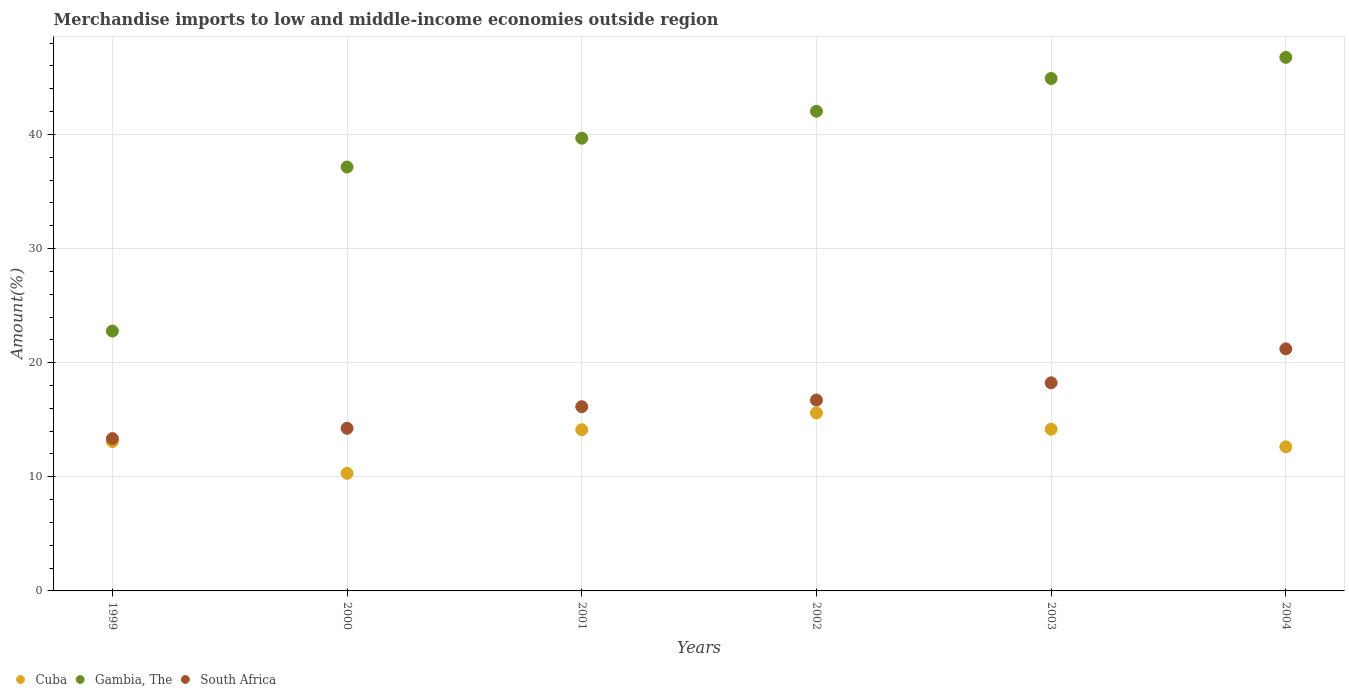What is the percentage of amount earned from merchandise imports in South Africa in 2003?
Offer a very short reply. 18.24. Across all years, what is the maximum percentage of amount earned from merchandise imports in Cuba?
Your answer should be very brief. 15.6. Across all years, what is the minimum percentage of amount earned from merchandise imports in South Africa?
Provide a succinct answer. 13.35. In which year was the percentage of amount earned from merchandise imports in South Africa maximum?
Keep it short and to the point. 2004. In which year was the percentage of amount earned from merchandise imports in South Africa minimum?
Keep it short and to the point. 1999. What is the total percentage of amount earned from merchandise imports in Gambia, The in the graph?
Provide a short and direct response. 233.27. What is the difference between the percentage of amount earned from merchandise imports in South Africa in 2000 and that in 2002?
Make the answer very short. -2.48. What is the difference between the percentage of amount earned from merchandise imports in Gambia, The in 2004 and the percentage of amount earned from merchandise imports in South Africa in 2000?
Make the answer very short. 32.5. What is the average percentage of amount earned from merchandise imports in Gambia, The per year?
Offer a terse response. 38.88. In the year 2001, what is the difference between the percentage of amount earned from merchandise imports in Gambia, The and percentage of amount earned from merchandise imports in South Africa?
Ensure brevity in your answer.  23.53. In how many years, is the percentage of amount earned from merchandise imports in South Africa greater than 4 %?
Provide a succinct answer. 6. What is the ratio of the percentage of amount earned from merchandise imports in South Africa in 2000 to that in 2002?
Ensure brevity in your answer.  0.85. Is the difference between the percentage of amount earned from merchandise imports in Gambia, The in 1999 and 2004 greater than the difference between the percentage of amount earned from merchandise imports in South Africa in 1999 and 2004?
Provide a short and direct response. No. What is the difference between the highest and the second highest percentage of amount earned from merchandise imports in Cuba?
Offer a terse response. 1.43. What is the difference between the highest and the lowest percentage of amount earned from merchandise imports in South Africa?
Offer a very short reply. 7.86. In how many years, is the percentage of amount earned from merchandise imports in Cuba greater than the average percentage of amount earned from merchandise imports in Cuba taken over all years?
Make the answer very short. 3. Is the sum of the percentage of amount earned from merchandise imports in Cuba in 1999 and 2000 greater than the maximum percentage of amount earned from merchandise imports in Gambia, The across all years?
Your answer should be compact. No. Is the percentage of amount earned from merchandise imports in South Africa strictly less than the percentage of amount earned from merchandise imports in Gambia, The over the years?
Your response must be concise. Yes. How many dotlines are there?
Your response must be concise. 3. What is the difference between two consecutive major ticks on the Y-axis?
Make the answer very short. 10. Are the values on the major ticks of Y-axis written in scientific E-notation?
Give a very brief answer. No. Does the graph contain any zero values?
Keep it short and to the point. No. Does the graph contain grids?
Your answer should be compact. Yes. Where does the legend appear in the graph?
Your response must be concise. Bottom left. How are the legend labels stacked?
Give a very brief answer. Horizontal. What is the title of the graph?
Offer a terse response. Merchandise imports to low and middle-income economies outside region. Does "Cameroon" appear as one of the legend labels in the graph?
Provide a succinct answer. No. What is the label or title of the X-axis?
Provide a short and direct response. Years. What is the label or title of the Y-axis?
Ensure brevity in your answer.  Amount(%). What is the Amount(%) of Cuba in 1999?
Give a very brief answer. 13.09. What is the Amount(%) in Gambia, The in 1999?
Provide a short and direct response. 22.77. What is the Amount(%) in South Africa in 1999?
Your answer should be very brief. 13.35. What is the Amount(%) of Cuba in 2000?
Offer a very short reply. 10.3. What is the Amount(%) in Gambia, The in 2000?
Provide a short and direct response. 37.14. What is the Amount(%) of South Africa in 2000?
Keep it short and to the point. 14.25. What is the Amount(%) in Cuba in 2001?
Offer a very short reply. 14.12. What is the Amount(%) in Gambia, The in 2001?
Make the answer very short. 39.67. What is the Amount(%) in South Africa in 2001?
Your answer should be compact. 16.14. What is the Amount(%) in Cuba in 2002?
Give a very brief answer. 15.6. What is the Amount(%) of Gambia, The in 2002?
Offer a very short reply. 42.03. What is the Amount(%) of South Africa in 2002?
Make the answer very short. 16.73. What is the Amount(%) in Cuba in 2003?
Provide a succinct answer. 14.17. What is the Amount(%) in Gambia, The in 2003?
Keep it short and to the point. 44.9. What is the Amount(%) of South Africa in 2003?
Offer a very short reply. 18.24. What is the Amount(%) in Cuba in 2004?
Your answer should be compact. 12.63. What is the Amount(%) in Gambia, The in 2004?
Your response must be concise. 46.75. What is the Amount(%) of South Africa in 2004?
Your answer should be very brief. 21.21. Across all years, what is the maximum Amount(%) of Cuba?
Your answer should be compact. 15.6. Across all years, what is the maximum Amount(%) in Gambia, The?
Provide a succinct answer. 46.75. Across all years, what is the maximum Amount(%) of South Africa?
Offer a terse response. 21.21. Across all years, what is the minimum Amount(%) in Cuba?
Offer a very short reply. 10.3. Across all years, what is the minimum Amount(%) of Gambia, The?
Offer a very short reply. 22.77. Across all years, what is the minimum Amount(%) of South Africa?
Offer a terse response. 13.35. What is the total Amount(%) in Cuba in the graph?
Ensure brevity in your answer.  79.91. What is the total Amount(%) in Gambia, The in the graph?
Keep it short and to the point. 233.27. What is the total Amount(%) of South Africa in the graph?
Keep it short and to the point. 99.91. What is the difference between the Amount(%) of Cuba in 1999 and that in 2000?
Keep it short and to the point. 2.79. What is the difference between the Amount(%) in Gambia, The in 1999 and that in 2000?
Your answer should be compact. -14.37. What is the difference between the Amount(%) in South Africa in 1999 and that in 2000?
Your answer should be very brief. -0.9. What is the difference between the Amount(%) in Cuba in 1999 and that in 2001?
Make the answer very short. -1.04. What is the difference between the Amount(%) of Gambia, The in 1999 and that in 2001?
Offer a very short reply. -16.9. What is the difference between the Amount(%) in South Africa in 1999 and that in 2001?
Keep it short and to the point. -2.79. What is the difference between the Amount(%) in Cuba in 1999 and that in 2002?
Provide a short and direct response. -2.51. What is the difference between the Amount(%) of Gambia, The in 1999 and that in 2002?
Your answer should be compact. -19.26. What is the difference between the Amount(%) in South Africa in 1999 and that in 2002?
Give a very brief answer. -3.38. What is the difference between the Amount(%) in Cuba in 1999 and that in 2003?
Your answer should be compact. -1.08. What is the difference between the Amount(%) in Gambia, The in 1999 and that in 2003?
Offer a very short reply. -22.13. What is the difference between the Amount(%) of South Africa in 1999 and that in 2003?
Ensure brevity in your answer.  -4.89. What is the difference between the Amount(%) of Cuba in 1999 and that in 2004?
Your answer should be very brief. 0.46. What is the difference between the Amount(%) of Gambia, The in 1999 and that in 2004?
Offer a terse response. -23.98. What is the difference between the Amount(%) of South Africa in 1999 and that in 2004?
Your response must be concise. -7.86. What is the difference between the Amount(%) in Cuba in 2000 and that in 2001?
Your answer should be compact. -3.82. What is the difference between the Amount(%) in Gambia, The in 2000 and that in 2001?
Keep it short and to the point. -2.52. What is the difference between the Amount(%) of South Africa in 2000 and that in 2001?
Offer a very short reply. -1.89. What is the difference between the Amount(%) of Cuba in 2000 and that in 2002?
Your answer should be compact. -5.29. What is the difference between the Amount(%) in Gambia, The in 2000 and that in 2002?
Offer a very short reply. -4.89. What is the difference between the Amount(%) in South Africa in 2000 and that in 2002?
Your answer should be very brief. -2.48. What is the difference between the Amount(%) in Cuba in 2000 and that in 2003?
Offer a terse response. -3.86. What is the difference between the Amount(%) of Gambia, The in 2000 and that in 2003?
Make the answer very short. -7.76. What is the difference between the Amount(%) of South Africa in 2000 and that in 2003?
Offer a very short reply. -3.99. What is the difference between the Amount(%) of Cuba in 2000 and that in 2004?
Provide a succinct answer. -2.32. What is the difference between the Amount(%) of Gambia, The in 2000 and that in 2004?
Keep it short and to the point. -9.61. What is the difference between the Amount(%) of South Africa in 2000 and that in 2004?
Your answer should be very brief. -6.96. What is the difference between the Amount(%) of Cuba in 2001 and that in 2002?
Provide a short and direct response. -1.47. What is the difference between the Amount(%) of Gambia, The in 2001 and that in 2002?
Make the answer very short. -2.36. What is the difference between the Amount(%) in South Africa in 2001 and that in 2002?
Provide a succinct answer. -0.59. What is the difference between the Amount(%) in Cuba in 2001 and that in 2003?
Give a very brief answer. -0.04. What is the difference between the Amount(%) in Gambia, The in 2001 and that in 2003?
Make the answer very short. -5.23. What is the difference between the Amount(%) in South Africa in 2001 and that in 2003?
Provide a succinct answer. -2.1. What is the difference between the Amount(%) in Cuba in 2001 and that in 2004?
Your response must be concise. 1.5. What is the difference between the Amount(%) of Gambia, The in 2001 and that in 2004?
Keep it short and to the point. -7.08. What is the difference between the Amount(%) in South Africa in 2001 and that in 2004?
Keep it short and to the point. -5.07. What is the difference between the Amount(%) of Cuba in 2002 and that in 2003?
Keep it short and to the point. 1.43. What is the difference between the Amount(%) in Gambia, The in 2002 and that in 2003?
Provide a succinct answer. -2.87. What is the difference between the Amount(%) in South Africa in 2002 and that in 2003?
Make the answer very short. -1.51. What is the difference between the Amount(%) in Cuba in 2002 and that in 2004?
Keep it short and to the point. 2.97. What is the difference between the Amount(%) in Gambia, The in 2002 and that in 2004?
Keep it short and to the point. -4.72. What is the difference between the Amount(%) of South Africa in 2002 and that in 2004?
Your answer should be compact. -4.48. What is the difference between the Amount(%) of Cuba in 2003 and that in 2004?
Give a very brief answer. 1.54. What is the difference between the Amount(%) in Gambia, The in 2003 and that in 2004?
Offer a terse response. -1.85. What is the difference between the Amount(%) in South Africa in 2003 and that in 2004?
Ensure brevity in your answer.  -2.97. What is the difference between the Amount(%) in Cuba in 1999 and the Amount(%) in Gambia, The in 2000?
Your answer should be very brief. -24.05. What is the difference between the Amount(%) of Cuba in 1999 and the Amount(%) of South Africa in 2000?
Offer a terse response. -1.16. What is the difference between the Amount(%) of Gambia, The in 1999 and the Amount(%) of South Africa in 2000?
Your answer should be compact. 8.52. What is the difference between the Amount(%) in Cuba in 1999 and the Amount(%) in Gambia, The in 2001?
Offer a terse response. -26.58. What is the difference between the Amount(%) in Cuba in 1999 and the Amount(%) in South Africa in 2001?
Ensure brevity in your answer.  -3.05. What is the difference between the Amount(%) in Gambia, The in 1999 and the Amount(%) in South Africa in 2001?
Offer a terse response. 6.63. What is the difference between the Amount(%) in Cuba in 1999 and the Amount(%) in Gambia, The in 2002?
Keep it short and to the point. -28.94. What is the difference between the Amount(%) in Cuba in 1999 and the Amount(%) in South Africa in 2002?
Ensure brevity in your answer.  -3.64. What is the difference between the Amount(%) of Gambia, The in 1999 and the Amount(%) of South Africa in 2002?
Offer a terse response. 6.04. What is the difference between the Amount(%) of Cuba in 1999 and the Amount(%) of Gambia, The in 2003?
Your answer should be very brief. -31.81. What is the difference between the Amount(%) of Cuba in 1999 and the Amount(%) of South Africa in 2003?
Keep it short and to the point. -5.15. What is the difference between the Amount(%) in Gambia, The in 1999 and the Amount(%) in South Africa in 2003?
Provide a short and direct response. 4.53. What is the difference between the Amount(%) in Cuba in 1999 and the Amount(%) in Gambia, The in 2004?
Give a very brief answer. -33.66. What is the difference between the Amount(%) of Cuba in 1999 and the Amount(%) of South Africa in 2004?
Your response must be concise. -8.12. What is the difference between the Amount(%) in Gambia, The in 1999 and the Amount(%) in South Africa in 2004?
Provide a short and direct response. 1.56. What is the difference between the Amount(%) in Cuba in 2000 and the Amount(%) in Gambia, The in 2001?
Your response must be concise. -29.36. What is the difference between the Amount(%) in Cuba in 2000 and the Amount(%) in South Africa in 2001?
Your answer should be very brief. -5.84. What is the difference between the Amount(%) of Gambia, The in 2000 and the Amount(%) of South Africa in 2001?
Your answer should be compact. 21. What is the difference between the Amount(%) in Cuba in 2000 and the Amount(%) in Gambia, The in 2002?
Your answer should be very brief. -31.73. What is the difference between the Amount(%) of Cuba in 2000 and the Amount(%) of South Africa in 2002?
Your response must be concise. -6.42. What is the difference between the Amount(%) of Gambia, The in 2000 and the Amount(%) of South Africa in 2002?
Make the answer very short. 20.42. What is the difference between the Amount(%) in Cuba in 2000 and the Amount(%) in Gambia, The in 2003?
Give a very brief answer. -34.6. What is the difference between the Amount(%) in Cuba in 2000 and the Amount(%) in South Africa in 2003?
Your answer should be compact. -7.93. What is the difference between the Amount(%) of Gambia, The in 2000 and the Amount(%) of South Africa in 2003?
Provide a succinct answer. 18.91. What is the difference between the Amount(%) of Cuba in 2000 and the Amount(%) of Gambia, The in 2004?
Provide a short and direct response. -36.45. What is the difference between the Amount(%) in Cuba in 2000 and the Amount(%) in South Africa in 2004?
Your answer should be compact. -10.91. What is the difference between the Amount(%) in Gambia, The in 2000 and the Amount(%) in South Africa in 2004?
Make the answer very short. 15.93. What is the difference between the Amount(%) of Cuba in 2001 and the Amount(%) of Gambia, The in 2002?
Offer a very short reply. -27.91. What is the difference between the Amount(%) of Cuba in 2001 and the Amount(%) of South Africa in 2002?
Your answer should be compact. -2.6. What is the difference between the Amount(%) of Gambia, The in 2001 and the Amount(%) of South Africa in 2002?
Your response must be concise. 22.94. What is the difference between the Amount(%) in Cuba in 2001 and the Amount(%) in Gambia, The in 2003?
Make the answer very short. -30.78. What is the difference between the Amount(%) in Cuba in 2001 and the Amount(%) in South Africa in 2003?
Offer a very short reply. -4.11. What is the difference between the Amount(%) in Gambia, The in 2001 and the Amount(%) in South Africa in 2003?
Your answer should be compact. 21.43. What is the difference between the Amount(%) of Cuba in 2001 and the Amount(%) of Gambia, The in 2004?
Provide a short and direct response. -32.63. What is the difference between the Amount(%) in Cuba in 2001 and the Amount(%) in South Africa in 2004?
Your answer should be very brief. -7.09. What is the difference between the Amount(%) in Gambia, The in 2001 and the Amount(%) in South Africa in 2004?
Keep it short and to the point. 18.46. What is the difference between the Amount(%) in Cuba in 2002 and the Amount(%) in Gambia, The in 2003?
Your answer should be very brief. -29.3. What is the difference between the Amount(%) in Cuba in 2002 and the Amount(%) in South Africa in 2003?
Ensure brevity in your answer.  -2.64. What is the difference between the Amount(%) of Gambia, The in 2002 and the Amount(%) of South Africa in 2003?
Offer a terse response. 23.79. What is the difference between the Amount(%) of Cuba in 2002 and the Amount(%) of Gambia, The in 2004?
Provide a short and direct response. -31.15. What is the difference between the Amount(%) of Cuba in 2002 and the Amount(%) of South Africa in 2004?
Provide a short and direct response. -5.61. What is the difference between the Amount(%) in Gambia, The in 2002 and the Amount(%) in South Africa in 2004?
Your answer should be very brief. 20.82. What is the difference between the Amount(%) of Cuba in 2003 and the Amount(%) of Gambia, The in 2004?
Offer a terse response. -32.58. What is the difference between the Amount(%) in Cuba in 2003 and the Amount(%) in South Africa in 2004?
Offer a terse response. -7.04. What is the difference between the Amount(%) of Gambia, The in 2003 and the Amount(%) of South Africa in 2004?
Your answer should be very brief. 23.69. What is the average Amount(%) in Cuba per year?
Ensure brevity in your answer.  13.32. What is the average Amount(%) in Gambia, The per year?
Keep it short and to the point. 38.88. What is the average Amount(%) of South Africa per year?
Keep it short and to the point. 16.65. In the year 1999, what is the difference between the Amount(%) of Cuba and Amount(%) of Gambia, The?
Keep it short and to the point. -9.68. In the year 1999, what is the difference between the Amount(%) of Cuba and Amount(%) of South Africa?
Provide a succinct answer. -0.26. In the year 1999, what is the difference between the Amount(%) in Gambia, The and Amount(%) in South Africa?
Give a very brief answer. 9.42. In the year 2000, what is the difference between the Amount(%) in Cuba and Amount(%) in Gambia, The?
Your answer should be compact. -26.84. In the year 2000, what is the difference between the Amount(%) in Cuba and Amount(%) in South Africa?
Give a very brief answer. -3.95. In the year 2000, what is the difference between the Amount(%) of Gambia, The and Amount(%) of South Africa?
Make the answer very short. 22.89. In the year 2001, what is the difference between the Amount(%) of Cuba and Amount(%) of Gambia, The?
Your response must be concise. -25.54. In the year 2001, what is the difference between the Amount(%) of Cuba and Amount(%) of South Africa?
Provide a short and direct response. -2.02. In the year 2001, what is the difference between the Amount(%) in Gambia, The and Amount(%) in South Africa?
Keep it short and to the point. 23.53. In the year 2002, what is the difference between the Amount(%) of Cuba and Amount(%) of Gambia, The?
Provide a short and direct response. -26.43. In the year 2002, what is the difference between the Amount(%) in Cuba and Amount(%) in South Africa?
Offer a terse response. -1.13. In the year 2002, what is the difference between the Amount(%) of Gambia, The and Amount(%) of South Africa?
Provide a succinct answer. 25.3. In the year 2003, what is the difference between the Amount(%) of Cuba and Amount(%) of Gambia, The?
Your answer should be very brief. -30.73. In the year 2003, what is the difference between the Amount(%) in Cuba and Amount(%) in South Africa?
Make the answer very short. -4.07. In the year 2003, what is the difference between the Amount(%) in Gambia, The and Amount(%) in South Africa?
Your answer should be very brief. 26.66. In the year 2004, what is the difference between the Amount(%) of Cuba and Amount(%) of Gambia, The?
Provide a succinct answer. -34.12. In the year 2004, what is the difference between the Amount(%) of Cuba and Amount(%) of South Africa?
Make the answer very short. -8.58. In the year 2004, what is the difference between the Amount(%) of Gambia, The and Amount(%) of South Africa?
Provide a short and direct response. 25.54. What is the ratio of the Amount(%) in Cuba in 1999 to that in 2000?
Make the answer very short. 1.27. What is the ratio of the Amount(%) of Gambia, The in 1999 to that in 2000?
Provide a succinct answer. 0.61. What is the ratio of the Amount(%) in South Africa in 1999 to that in 2000?
Provide a short and direct response. 0.94. What is the ratio of the Amount(%) in Cuba in 1999 to that in 2001?
Provide a short and direct response. 0.93. What is the ratio of the Amount(%) in Gambia, The in 1999 to that in 2001?
Offer a terse response. 0.57. What is the ratio of the Amount(%) in South Africa in 1999 to that in 2001?
Offer a very short reply. 0.83. What is the ratio of the Amount(%) in Cuba in 1999 to that in 2002?
Offer a very short reply. 0.84. What is the ratio of the Amount(%) in Gambia, The in 1999 to that in 2002?
Your response must be concise. 0.54. What is the ratio of the Amount(%) of South Africa in 1999 to that in 2002?
Ensure brevity in your answer.  0.8. What is the ratio of the Amount(%) in Cuba in 1999 to that in 2003?
Your answer should be very brief. 0.92. What is the ratio of the Amount(%) of Gambia, The in 1999 to that in 2003?
Ensure brevity in your answer.  0.51. What is the ratio of the Amount(%) in South Africa in 1999 to that in 2003?
Give a very brief answer. 0.73. What is the ratio of the Amount(%) in Cuba in 1999 to that in 2004?
Offer a very short reply. 1.04. What is the ratio of the Amount(%) of Gambia, The in 1999 to that in 2004?
Offer a very short reply. 0.49. What is the ratio of the Amount(%) in South Africa in 1999 to that in 2004?
Your answer should be compact. 0.63. What is the ratio of the Amount(%) in Cuba in 2000 to that in 2001?
Make the answer very short. 0.73. What is the ratio of the Amount(%) in Gambia, The in 2000 to that in 2001?
Make the answer very short. 0.94. What is the ratio of the Amount(%) of South Africa in 2000 to that in 2001?
Offer a very short reply. 0.88. What is the ratio of the Amount(%) of Cuba in 2000 to that in 2002?
Give a very brief answer. 0.66. What is the ratio of the Amount(%) in Gambia, The in 2000 to that in 2002?
Your response must be concise. 0.88. What is the ratio of the Amount(%) of South Africa in 2000 to that in 2002?
Your answer should be very brief. 0.85. What is the ratio of the Amount(%) in Cuba in 2000 to that in 2003?
Make the answer very short. 0.73. What is the ratio of the Amount(%) of Gambia, The in 2000 to that in 2003?
Give a very brief answer. 0.83. What is the ratio of the Amount(%) in South Africa in 2000 to that in 2003?
Give a very brief answer. 0.78. What is the ratio of the Amount(%) in Cuba in 2000 to that in 2004?
Your response must be concise. 0.82. What is the ratio of the Amount(%) in Gambia, The in 2000 to that in 2004?
Keep it short and to the point. 0.79. What is the ratio of the Amount(%) of South Africa in 2000 to that in 2004?
Give a very brief answer. 0.67. What is the ratio of the Amount(%) in Cuba in 2001 to that in 2002?
Offer a very short reply. 0.91. What is the ratio of the Amount(%) in Gambia, The in 2001 to that in 2002?
Offer a very short reply. 0.94. What is the ratio of the Amount(%) in South Africa in 2001 to that in 2002?
Keep it short and to the point. 0.96. What is the ratio of the Amount(%) of Gambia, The in 2001 to that in 2003?
Offer a very short reply. 0.88. What is the ratio of the Amount(%) of South Africa in 2001 to that in 2003?
Offer a very short reply. 0.89. What is the ratio of the Amount(%) in Cuba in 2001 to that in 2004?
Your response must be concise. 1.12. What is the ratio of the Amount(%) in Gambia, The in 2001 to that in 2004?
Your answer should be compact. 0.85. What is the ratio of the Amount(%) in South Africa in 2001 to that in 2004?
Your response must be concise. 0.76. What is the ratio of the Amount(%) of Cuba in 2002 to that in 2003?
Offer a very short reply. 1.1. What is the ratio of the Amount(%) of Gambia, The in 2002 to that in 2003?
Offer a terse response. 0.94. What is the ratio of the Amount(%) in South Africa in 2002 to that in 2003?
Your response must be concise. 0.92. What is the ratio of the Amount(%) of Cuba in 2002 to that in 2004?
Keep it short and to the point. 1.24. What is the ratio of the Amount(%) in Gambia, The in 2002 to that in 2004?
Ensure brevity in your answer.  0.9. What is the ratio of the Amount(%) of South Africa in 2002 to that in 2004?
Make the answer very short. 0.79. What is the ratio of the Amount(%) of Cuba in 2003 to that in 2004?
Ensure brevity in your answer.  1.12. What is the ratio of the Amount(%) in Gambia, The in 2003 to that in 2004?
Make the answer very short. 0.96. What is the ratio of the Amount(%) in South Africa in 2003 to that in 2004?
Keep it short and to the point. 0.86. What is the difference between the highest and the second highest Amount(%) of Cuba?
Provide a short and direct response. 1.43. What is the difference between the highest and the second highest Amount(%) of Gambia, The?
Ensure brevity in your answer.  1.85. What is the difference between the highest and the second highest Amount(%) in South Africa?
Offer a very short reply. 2.97. What is the difference between the highest and the lowest Amount(%) in Cuba?
Keep it short and to the point. 5.29. What is the difference between the highest and the lowest Amount(%) of Gambia, The?
Offer a terse response. 23.98. What is the difference between the highest and the lowest Amount(%) in South Africa?
Your answer should be very brief. 7.86. 